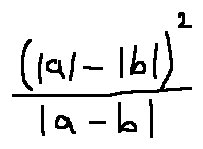Convert formula to latex. <formula><loc_0><loc_0><loc_500><loc_500>\frac { ( | a | - | b | ) ^ { 2 } } { | a - b | }</formula> 